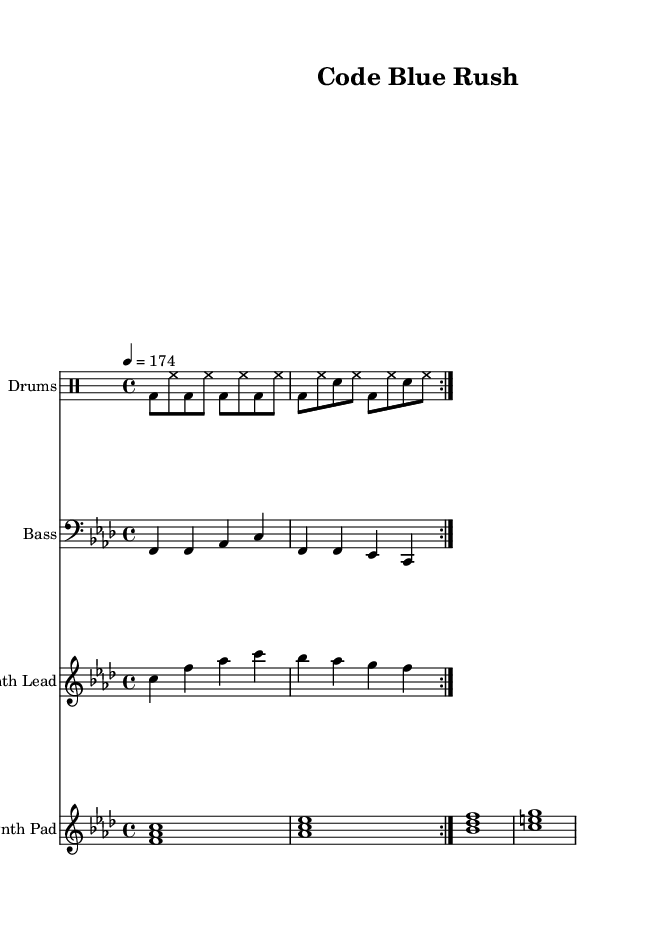What is the title of this music? The title is located in the header section of the sheet music, which clearly states "Code Blue Rush."
Answer: Code Blue Rush What is the key signature of this music? The key signature is indicated on the left side of the staff; the presence of four flats corresponds to F minor.
Answer: F minor What is the time signature of this music? The time signature is located at the beginning of the measure; it is marked as 4/4, meaning there are four beats per measure.
Answer: 4/4 What is the tempo of this music? The tempo is specified as 4 = 174, which means the tempo marking is indicating a quarter note equals 174 beats per minute.
Answer: 174 How many repetitions does the drum part have? The drum part is indicated by the notation "repeat volta 2," meaning it is played two times.
Answer: 2 What instruments are included in this composition? The score includes a Drum Staff for drums, a Staff for bass, a Staff for Synth Lead, and a Piano Staff for Synth Pad, indicating four distinct instruments.
Answer: Drums, Bass, Synth Lead, Synth Pad What type of music does this piece represent? The style of the music, indicated by the fast tempo, energetic rhythms, and electronic instrumentation, suggests it falls under the Electronic genre, specifically drum and bass.
Answer: Electronic, Drum and Bass 